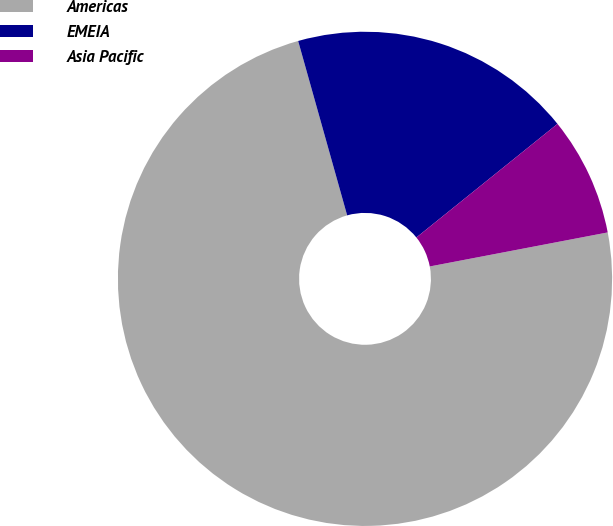Convert chart. <chart><loc_0><loc_0><loc_500><loc_500><pie_chart><fcel>Americas<fcel>EMEIA<fcel>Asia Pacific<nl><fcel>73.64%<fcel>18.57%<fcel>7.78%<nl></chart> 